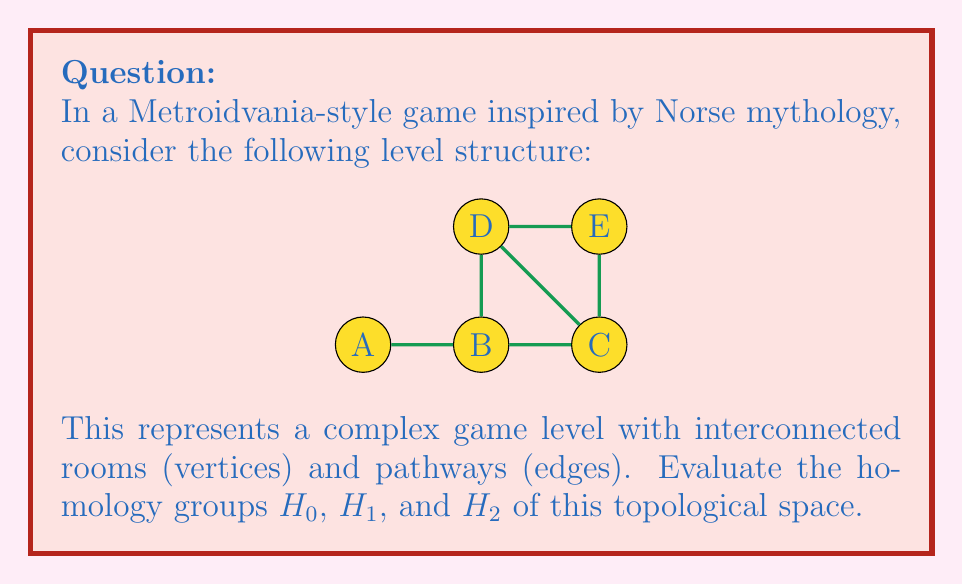Teach me how to tackle this problem. To evaluate the homology groups of this game level structure, we'll follow these steps:

1. Identify the simplicial complex:
   0-simplices (vertices): A, B, C, D, E
   1-simplices (edges): AB, BC, BE, CD, DE, DB
   2-simplices (faces): BCD, BCE

2. Calculate the Betti numbers:
   $\beta_0$: number of connected components
   $\beta_1$: number of 1-dimensional holes
   $\beta_2$: number of 2-dimensional voids

   $\beta_0 = 1$ (the entire structure is connected)
   $\beta_1 = 1$ (there is one cycle: BCDB)
   $\beta_2 = 0$ (no enclosed 3D spaces)

3. Determine the homology groups:

   $H_0$: This represents the number of connected components.
   $H_0 \cong \mathbb{Z}$ (one free generator)

   $H_1$: This represents the number of 1-dimensional holes.
   $H_1 \cong \mathbb{Z}$ (one free generator corresponding to the cycle BCDB)

   $H_2$: This represents the number of 2-dimensional voids.
   $H_2 \cong 0$ (trivial group, as there are no enclosed 3D spaces)

4. Express the homology groups in the standard notation:
   $H_0 \cong \mathbb{Z}$
   $H_1 \cong \mathbb{Z}$
   $H_2 \cong 0$
Answer: $H_0 \cong \mathbb{Z}, H_1 \cong \mathbb{Z}, H_2 \cong 0$ 